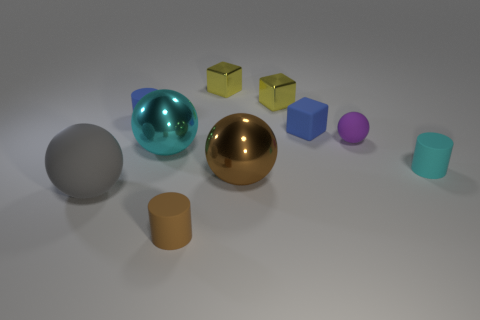Are the small cyan cylinder and the cyan ball made of the same material?
Provide a short and direct response. No. How many blocks are either small cyan matte objects or small purple rubber objects?
Provide a short and direct response. 0. There is a cylinder behind the small cyan thing on the right side of the cyan sphere; what color is it?
Offer a terse response. Blue. There is a thing that is the same color as the small rubber block; what size is it?
Give a very brief answer. Small. There is a matte cylinder behind the cylinder that is to the right of the small purple object; how many big gray balls are behind it?
Make the answer very short. 0. There is a tiny blue thing left of the large cyan shiny ball; is it the same shape as the tiny thing in front of the large gray matte ball?
Ensure brevity in your answer.  Yes. What number of objects are either small blue cubes or cubes?
Provide a short and direct response. 3. The cyan thing that is left of the small blue thing to the right of the small brown matte object is made of what material?
Your answer should be very brief. Metal. Is there a tiny metal thing of the same color as the small matte ball?
Provide a short and direct response. No. There is a rubber thing that is the same size as the brown metal ball; what is its color?
Provide a succinct answer. Gray. 